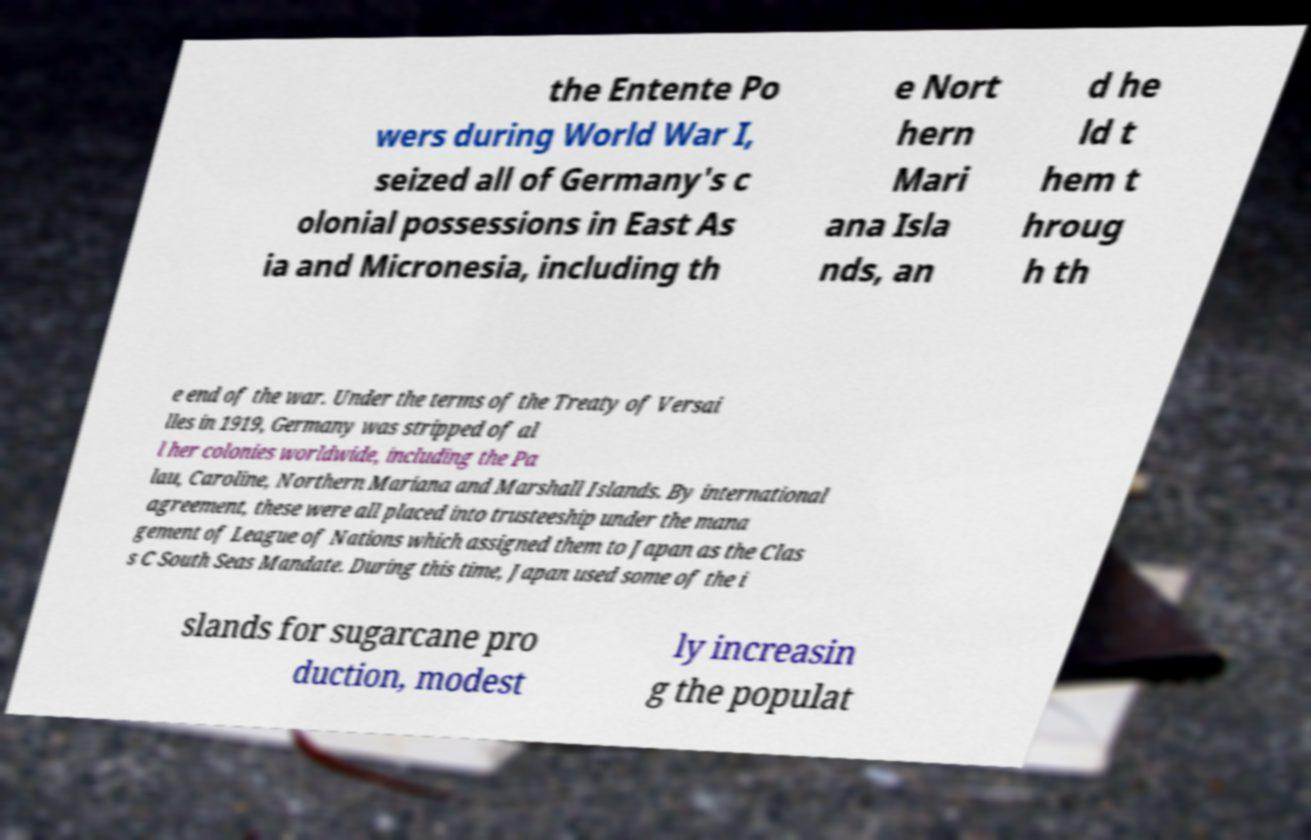What messages or text are displayed in this image? I need them in a readable, typed format. the Entente Po wers during World War I, seized all of Germany's c olonial possessions in East As ia and Micronesia, including th e Nort hern Mari ana Isla nds, an d he ld t hem t hroug h th e end of the war. Under the terms of the Treaty of Versai lles in 1919, Germany was stripped of al l her colonies worldwide, including the Pa lau, Caroline, Northern Mariana and Marshall Islands. By international agreement, these were all placed into trusteeship under the mana gement of League of Nations which assigned them to Japan as the Clas s C South Seas Mandate. During this time, Japan used some of the i slands for sugarcane pro duction, modest ly increasin g the populat 